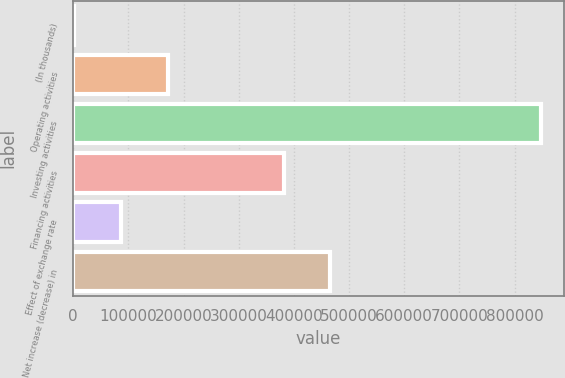Convert chart to OTSL. <chart><loc_0><loc_0><loc_500><loc_500><bar_chart><fcel>(In thousands)<fcel>Operating activities<fcel>Investing activities<fcel>Financing activities<fcel>Effect of exchange rate<fcel>Net increase (decrease) in<nl><fcel>2015<fcel>171107<fcel>847475<fcel>381433<fcel>86561<fcel>465979<nl></chart> 